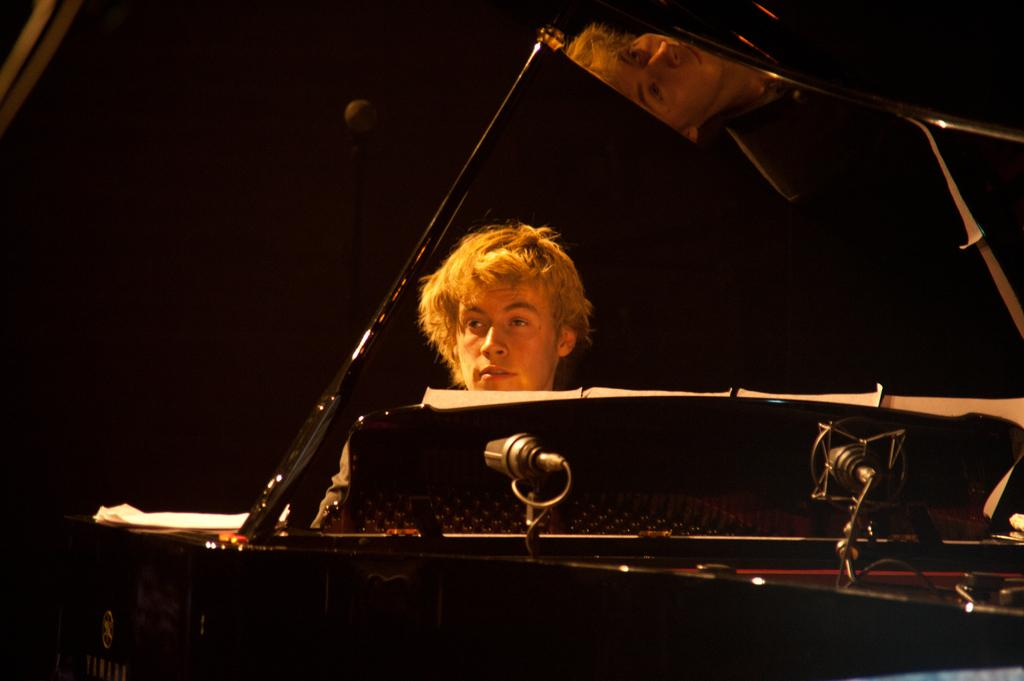Who is present in the image? There is a man in the image. What is in front of the man? There is an object in front of the man. How would you describe the background of the image? The background of the image is dark. Can you identify any specific colors in the image? Yes, there are white color things in the image. How many rings are visible on the man's fingers in the image? There is no mention of rings or any jewelry in the image, so it is not possible to determine the number of rings visible on the man's fingers. 